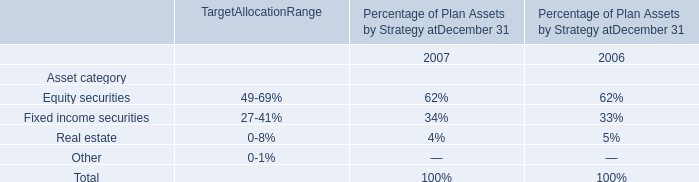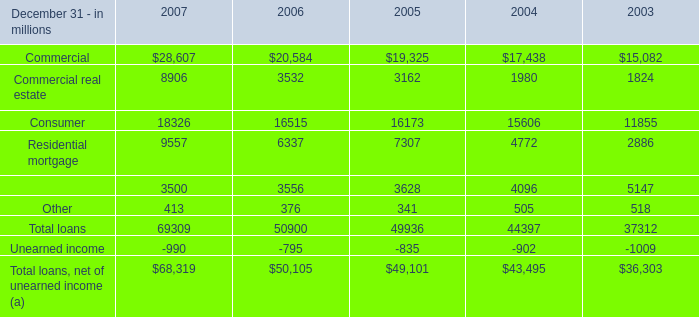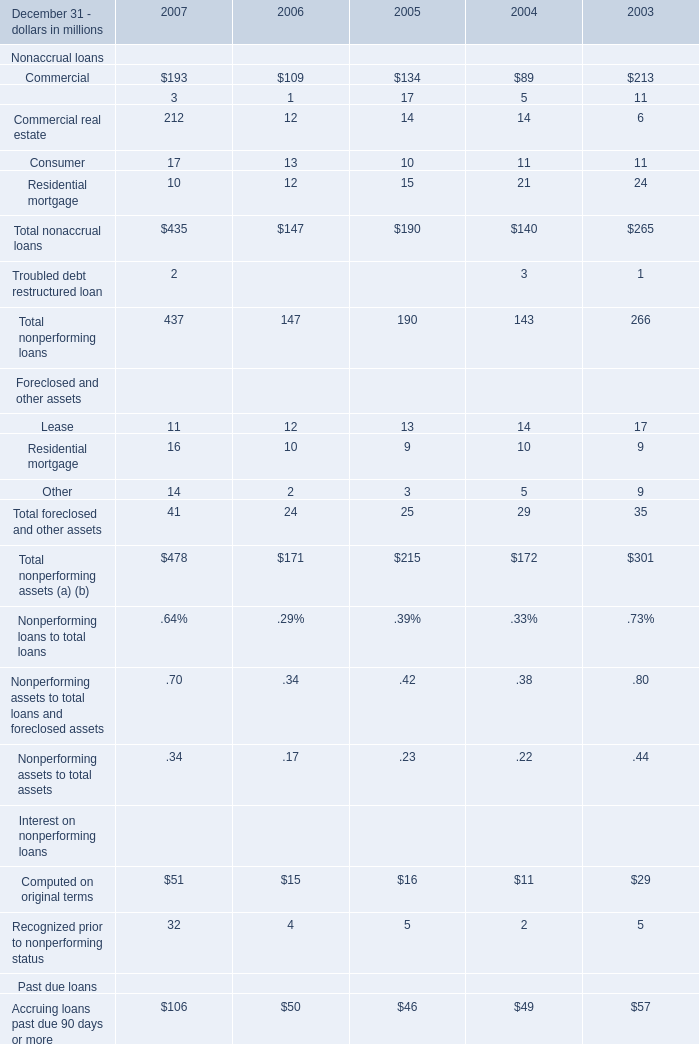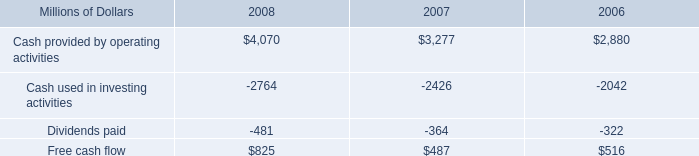In what year is Residential mortgage greater than 8000? 
Answer: 2007. 